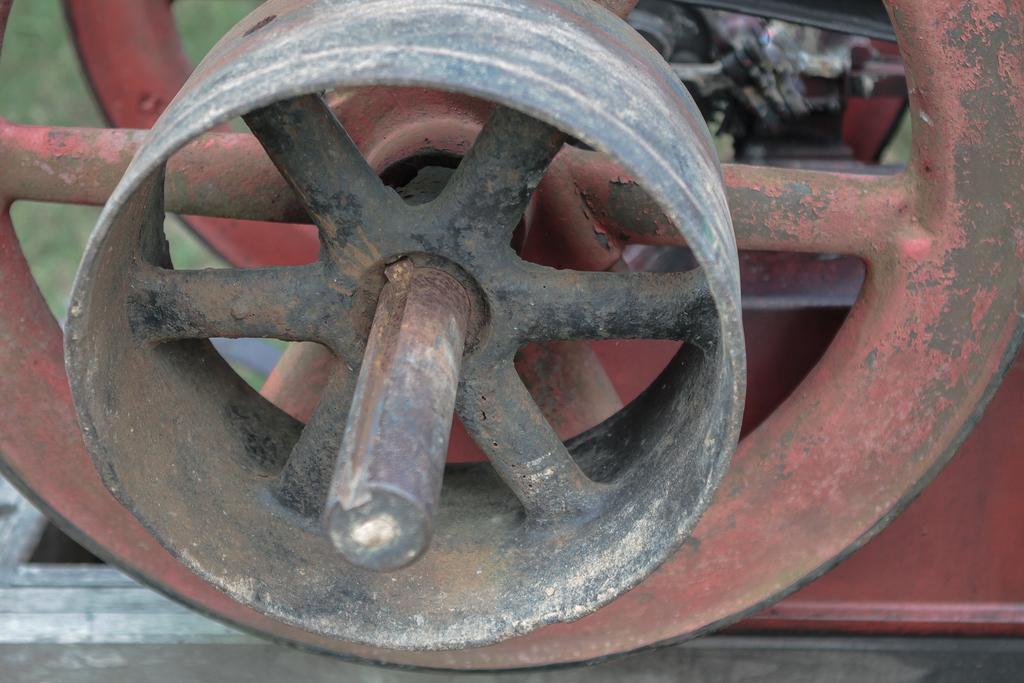How would you summarize this image in a sentence or two? In the center of the image there is some object. 